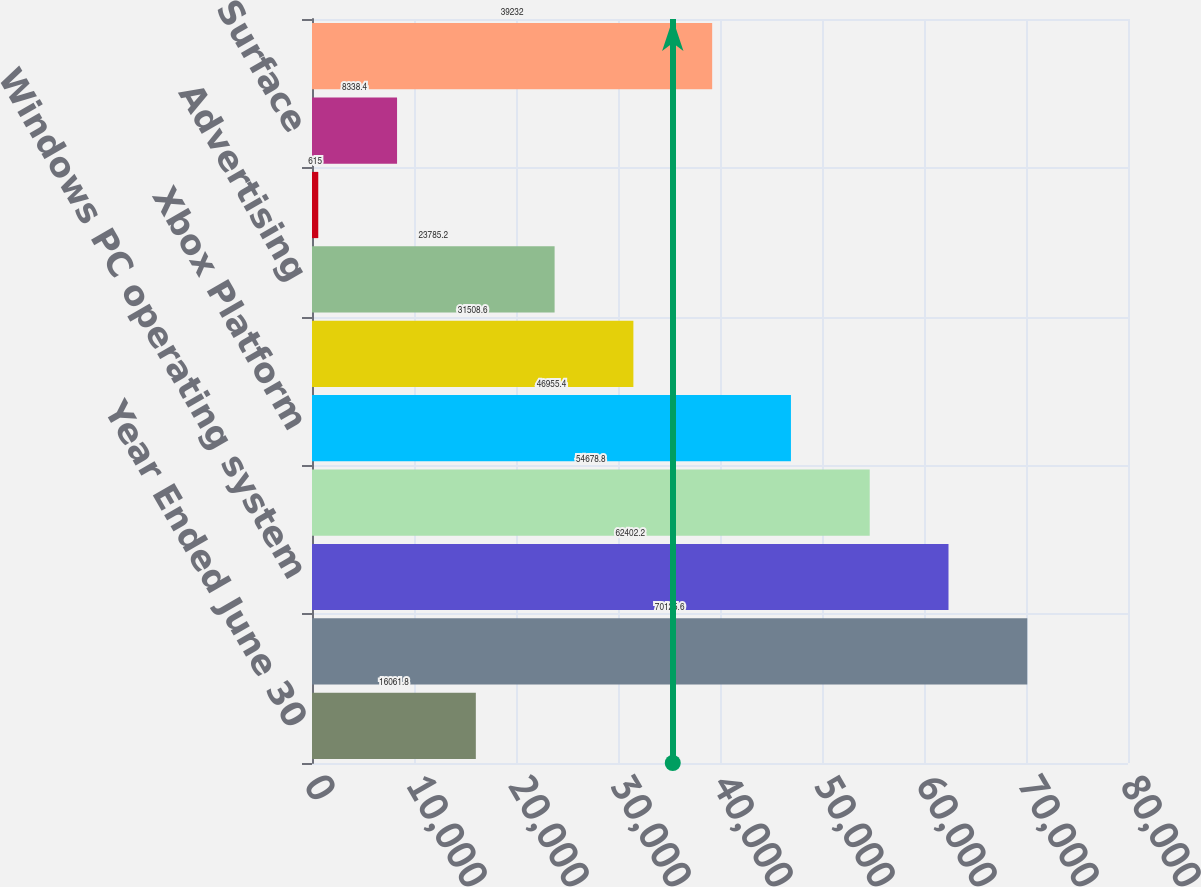Convert chart. <chart><loc_0><loc_0><loc_500><loc_500><bar_chart><fcel>Year Ended June 30<fcel>Microsoft Office system<fcel>Windows PC operating system<fcel>Server products and tools<fcel>Xbox Platform<fcel>Consulting and product support<fcel>Advertising<fcel>Phone<fcel>Surface<fcel>Other<nl><fcel>16061.8<fcel>70125.6<fcel>62402.2<fcel>54678.8<fcel>46955.4<fcel>31508.6<fcel>23785.2<fcel>615<fcel>8338.4<fcel>39232<nl></chart> 